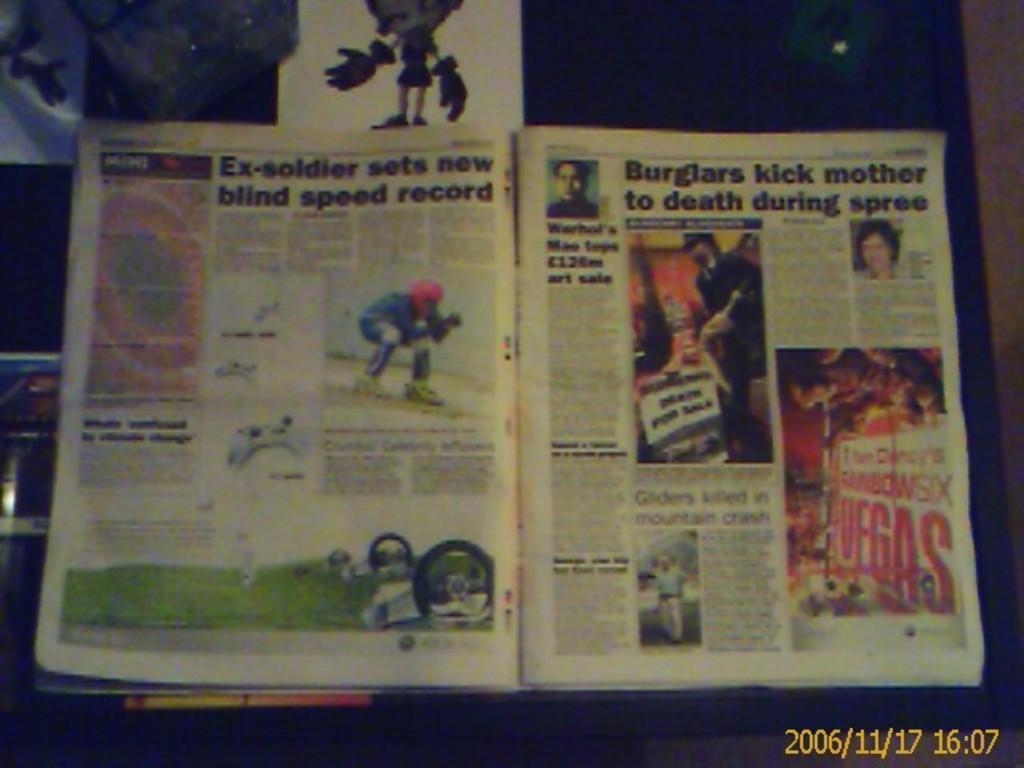What kind of record did the ex-soldier break?
Provide a short and direct response. Blind speed. 